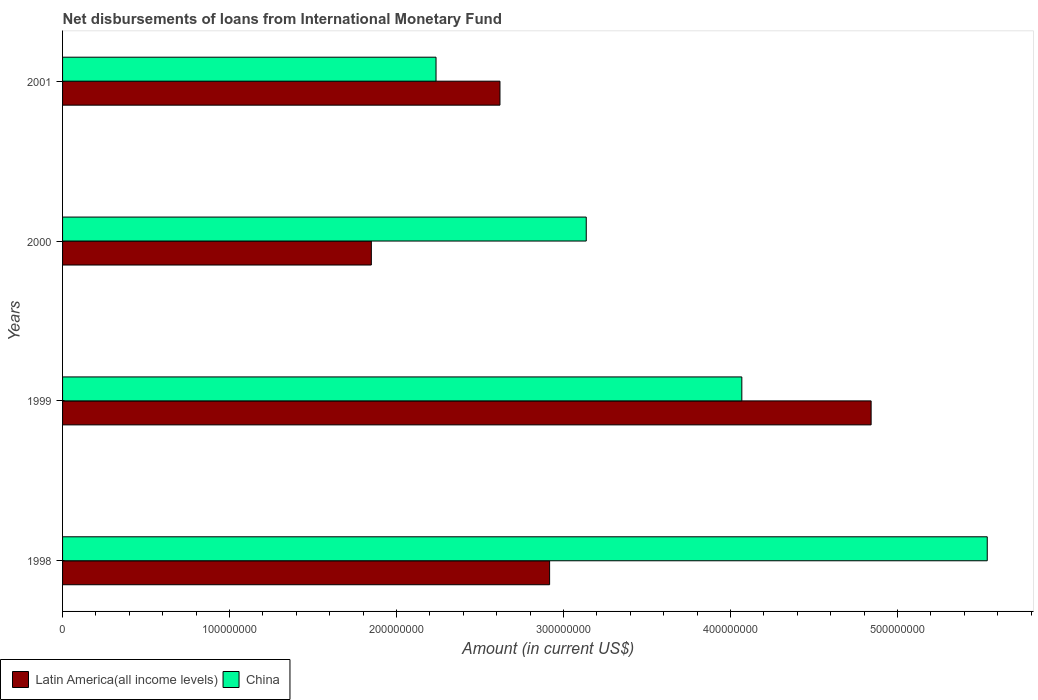How many groups of bars are there?
Provide a succinct answer. 4. Are the number of bars on each tick of the Y-axis equal?
Your response must be concise. Yes. How many bars are there on the 4th tick from the bottom?
Your response must be concise. 2. What is the amount of loans disbursed in Latin America(all income levels) in 2001?
Offer a very short reply. 2.62e+08. Across all years, what is the maximum amount of loans disbursed in Latin America(all income levels)?
Your answer should be very brief. 4.84e+08. Across all years, what is the minimum amount of loans disbursed in Latin America(all income levels)?
Your response must be concise. 1.85e+08. What is the total amount of loans disbursed in China in the graph?
Provide a short and direct response. 1.50e+09. What is the difference between the amount of loans disbursed in China in 1998 and that in 2001?
Your answer should be compact. 3.30e+08. What is the difference between the amount of loans disbursed in China in 2000 and the amount of loans disbursed in Latin America(all income levels) in 1998?
Make the answer very short. 2.19e+07. What is the average amount of loans disbursed in Latin America(all income levels) per year?
Make the answer very short. 3.06e+08. In the year 2000, what is the difference between the amount of loans disbursed in Latin America(all income levels) and amount of loans disbursed in China?
Ensure brevity in your answer.  -1.29e+08. What is the ratio of the amount of loans disbursed in Latin America(all income levels) in 1999 to that in 2000?
Provide a succinct answer. 2.62. Is the amount of loans disbursed in China in 1998 less than that in 2001?
Keep it short and to the point. No. Is the difference between the amount of loans disbursed in Latin America(all income levels) in 1998 and 2001 greater than the difference between the amount of loans disbursed in China in 1998 and 2001?
Your answer should be very brief. No. What is the difference between the highest and the second highest amount of loans disbursed in China?
Your answer should be compact. 1.47e+08. What is the difference between the highest and the lowest amount of loans disbursed in China?
Ensure brevity in your answer.  3.30e+08. Is the sum of the amount of loans disbursed in Latin America(all income levels) in 1999 and 2001 greater than the maximum amount of loans disbursed in China across all years?
Offer a very short reply. Yes. What does the 1st bar from the top in 2000 represents?
Offer a terse response. China. What is the difference between two consecutive major ticks on the X-axis?
Give a very brief answer. 1.00e+08. Does the graph contain grids?
Give a very brief answer. No. Where does the legend appear in the graph?
Give a very brief answer. Bottom left. How are the legend labels stacked?
Offer a terse response. Horizontal. What is the title of the graph?
Offer a very short reply. Net disbursements of loans from International Monetary Fund. What is the label or title of the X-axis?
Your answer should be compact. Amount (in current US$). What is the Amount (in current US$) in Latin America(all income levels) in 1998?
Your answer should be compact. 2.92e+08. What is the Amount (in current US$) in China in 1998?
Provide a succinct answer. 5.54e+08. What is the Amount (in current US$) of Latin America(all income levels) in 1999?
Give a very brief answer. 4.84e+08. What is the Amount (in current US$) in China in 1999?
Ensure brevity in your answer.  4.07e+08. What is the Amount (in current US$) in Latin America(all income levels) in 2000?
Offer a very short reply. 1.85e+08. What is the Amount (in current US$) in China in 2000?
Your answer should be compact. 3.14e+08. What is the Amount (in current US$) of Latin America(all income levels) in 2001?
Offer a terse response. 2.62e+08. What is the Amount (in current US$) in China in 2001?
Give a very brief answer. 2.24e+08. Across all years, what is the maximum Amount (in current US$) in Latin America(all income levels)?
Your answer should be compact. 4.84e+08. Across all years, what is the maximum Amount (in current US$) of China?
Your response must be concise. 5.54e+08. Across all years, what is the minimum Amount (in current US$) in Latin America(all income levels)?
Your answer should be compact. 1.85e+08. Across all years, what is the minimum Amount (in current US$) in China?
Offer a very short reply. 2.24e+08. What is the total Amount (in current US$) of Latin America(all income levels) in the graph?
Your answer should be compact. 1.22e+09. What is the total Amount (in current US$) in China in the graph?
Provide a succinct answer. 1.50e+09. What is the difference between the Amount (in current US$) of Latin America(all income levels) in 1998 and that in 1999?
Keep it short and to the point. -1.93e+08. What is the difference between the Amount (in current US$) in China in 1998 and that in 1999?
Your response must be concise. 1.47e+08. What is the difference between the Amount (in current US$) in Latin America(all income levels) in 1998 and that in 2000?
Provide a succinct answer. 1.07e+08. What is the difference between the Amount (in current US$) of China in 1998 and that in 2000?
Ensure brevity in your answer.  2.40e+08. What is the difference between the Amount (in current US$) in Latin America(all income levels) in 1998 and that in 2001?
Provide a short and direct response. 2.97e+07. What is the difference between the Amount (in current US$) in China in 1998 and that in 2001?
Your answer should be very brief. 3.30e+08. What is the difference between the Amount (in current US$) of Latin America(all income levels) in 1999 and that in 2000?
Your answer should be very brief. 2.99e+08. What is the difference between the Amount (in current US$) of China in 1999 and that in 2000?
Offer a very short reply. 9.32e+07. What is the difference between the Amount (in current US$) of Latin America(all income levels) in 1999 and that in 2001?
Your response must be concise. 2.22e+08. What is the difference between the Amount (in current US$) in China in 1999 and that in 2001?
Provide a short and direct response. 1.83e+08. What is the difference between the Amount (in current US$) of Latin America(all income levels) in 2000 and that in 2001?
Your answer should be very brief. -7.70e+07. What is the difference between the Amount (in current US$) of China in 2000 and that in 2001?
Offer a terse response. 9.00e+07. What is the difference between the Amount (in current US$) of Latin America(all income levels) in 1998 and the Amount (in current US$) of China in 1999?
Offer a terse response. -1.15e+08. What is the difference between the Amount (in current US$) of Latin America(all income levels) in 1998 and the Amount (in current US$) of China in 2000?
Provide a succinct answer. -2.19e+07. What is the difference between the Amount (in current US$) of Latin America(all income levels) in 1998 and the Amount (in current US$) of China in 2001?
Provide a succinct answer. 6.80e+07. What is the difference between the Amount (in current US$) of Latin America(all income levels) in 1999 and the Amount (in current US$) of China in 2000?
Ensure brevity in your answer.  1.71e+08. What is the difference between the Amount (in current US$) in Latin America(all income levels) in 1999 and the Amount (in current US$) in China in 2001?
Your answer should be compact. 2.61e+08. What is the difference between the Amount (in current US$) in Latin America(all income levels) in 2000 and the Amount (in current US$) in China in 2001?
Give a very brief answer. -3.87e+07. What is the average Amount (in current US$) of Latin America(all income levels) per year?
Keep it short and to the point. 3.06e+08. What is the average Amount (in current US$) in China per year?
Offer a terse response. 3.74e+08. In the year 1998, what is the difference between the Amount (in current US$) of Latin America(all income levels) and Amount (in current US$) of China?
Offer a very short reply. -2.62e+08. In the year 1999, what is the difference between the Amount (in current US$) in Latin America(all income levels) and Amount (in current US$) in China?
Give a very brief answer. 7.74e+07. In the year 2000, what is the difference between the Amount (in current US$) in Latin America(all income levels) and Amount (in current US$) in China?
Provide a succinct answer. -1.29e+08. In the year 2001, what is the difference between the Amount (in current US$) in Latin America(all income levels) and Amount (in current US$) in China?
Make the answer very short. 3.83e+07. What is the ratio of the Amount (in current US$) of Latin America(all income levels) in 1998 to that in 1999?
Ensure brevity in your answer.  0.6. What is the ratio of the Amount (in current US$) of China in 1998 to that in 1999?
Your answer should be very brief. 1.36. What is the ratio of the Amount (in current US$) of Latin America(all income levels) in 1998 to that in 2000?
Offer a terse response. 1.58. What is the ratio of the Amount (in current US$) in China in 1998 to that in 2000?
Provide a short and direct response. 1.77. What is the ratio of the Amount (in current US$) of Latin America(all income levels) in 1998 to that in 2001?
Your response must be concise. 1.11. What is the ratio of the Amount (in current US$) in China in 1998 to that in 2001?
Offer a terse response. 2.48. What is the ratio of the Amount (in current US$) of Latin America(all income levels) in 1999 to that in 2000?
Provide a succinct answer. 2.62. What is the ratio of the Amount (in current US$) in China in 1999 to that in 2000?
Offer a very short reply. 1.3. What is the ratio of the Amount (in current US$) in Latin America(all income levels) in 1999 to that in 2001?
Keep it short and to the point. 1.85. What is the ratio of the Amount (in current US$) in China in 1999 to that in 2001?
Your answer should be compact. 1.82. What is the ratio of the Amount (in current US$) in Latin America(all income levels) in 2000 to that in 2001?
Provide a short and direct response. 0.71. What is the ratio of the Amount (in current US$) of China in 2000 to that in 2001?
Provide a succinct answer. 1.4. What is the difference between the highest and the second highest Amount (in current US$) in Latin America(all income levels)?
Provide a short and direct response. 1.93e+08. What is the difference between the highest and the second highest Amount (in current US$) of China?
Give a very brief answer. 1.47e+08. What is the difference between the highest and the lowest Amount (in current US$) in Latin America(all income levels)?
Your response must be concise. 2.99e+08. What is the difference between the highest and the lowest Amount (in current US$) in China?
Ensure brevity in your answer.  3.30e+08. 